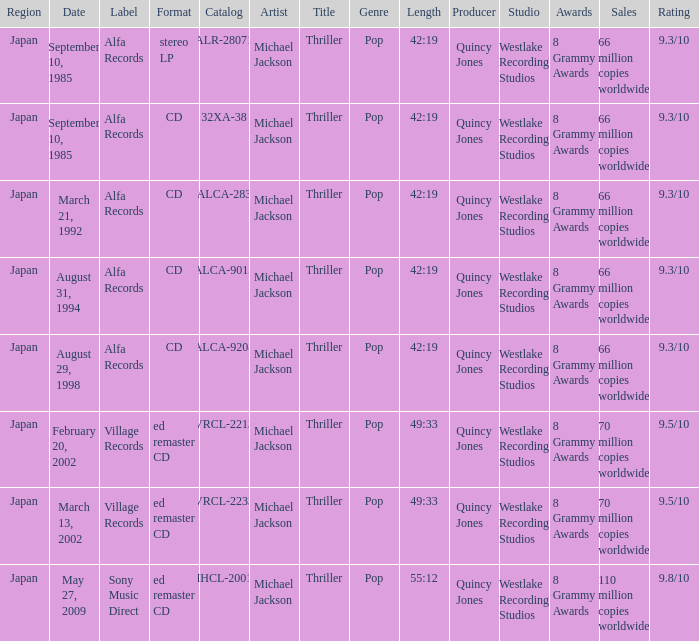Which Label was cataloged as alca-9013? Alfa Records. 